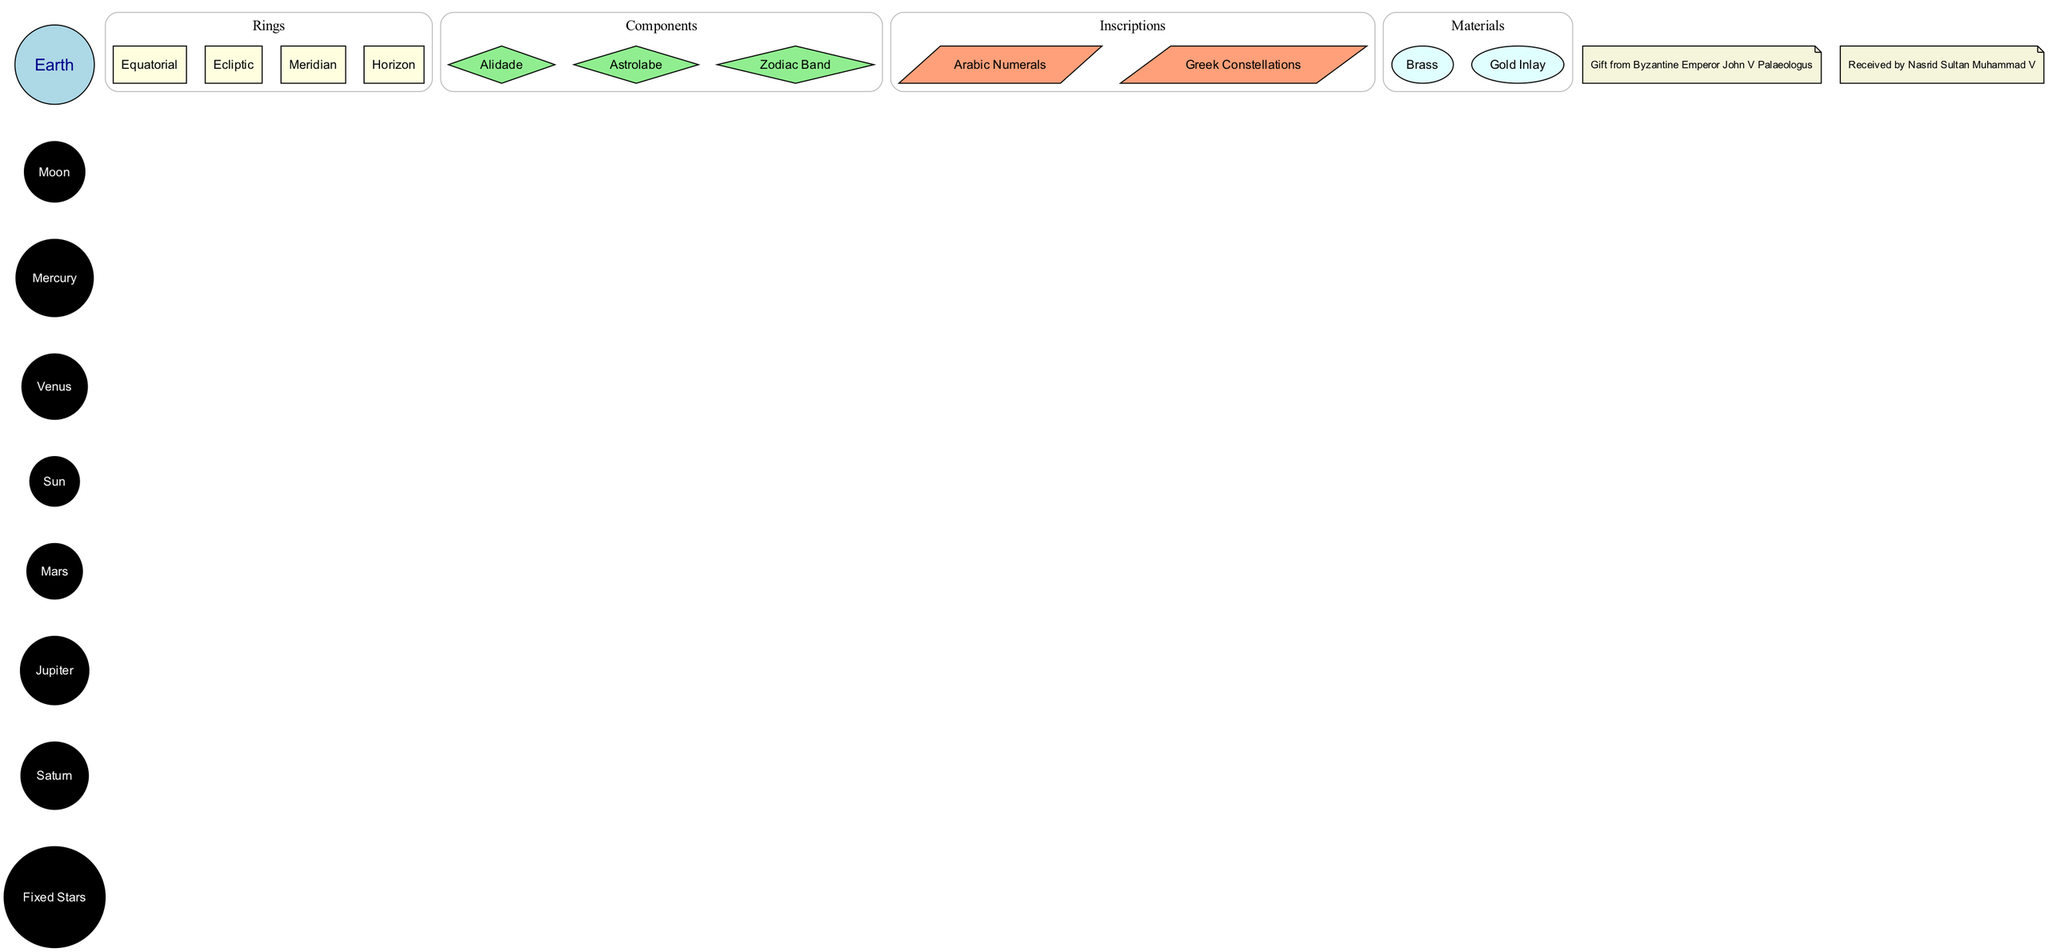What is at the center of the armillary sphere? The diagram identifies the central node as "Earth," representing the location of the Earth in the armillary sphere.
Answer: Earth How many celestial spheres are represented in the diagram? By counting the nodes listed under the "celestial_spheres" category, there are a total of eight spheres displayed.
Answer: 8 What are the four types of rings displayed in the armillary sphere? The diagram lists four rings: Equatorial, Ecliptic, Meridian, and Horizon, under the "Rings" subgraph.
Answer: Equatorial, Ecliptic, Meridian, Horizon Which component is shaped like a diamond? The "Astrolabe" is included among the components specifically marked as having a diamond shape in the diagram.
Answer: Astrolabe How many historical contexts are noted in the diagram? By counting the nodes that are labeled under the "historical_context" section, there are two noted contexts represented in the diagram.
Answer: 2 What materials are indicated to be used in the armillary sphere? The diagram categorizes the materials into two specific types: Brass and Gold Inlay, as noted in the "Materials" subgraph.
Answer: Brass, Gold Inlay Which celestial body is connected to the Earth in the diagram? The diagram connects the central node "Earth" to the first celestial sphere, which is the "Moon," indicating its direct relationship.
Answer: Moon What inscriptions are featured on the armillary sphere? The diagram mentions two types of inscriptions: Arabic Numerals and Greek Constellations, which can be seen in the "Inscriptions" subgraph.
Answer: Arabic Numerals, Greek Constellations What significant event is noted regarding the Nasrid Sultan in the historical context? The historical context indicates that the armillary sphere was "Received by Nasrid Sultan Muhammad V," highlighting his connection to this object.
Answer: Received by Nasrid Sultan Muhammad V 